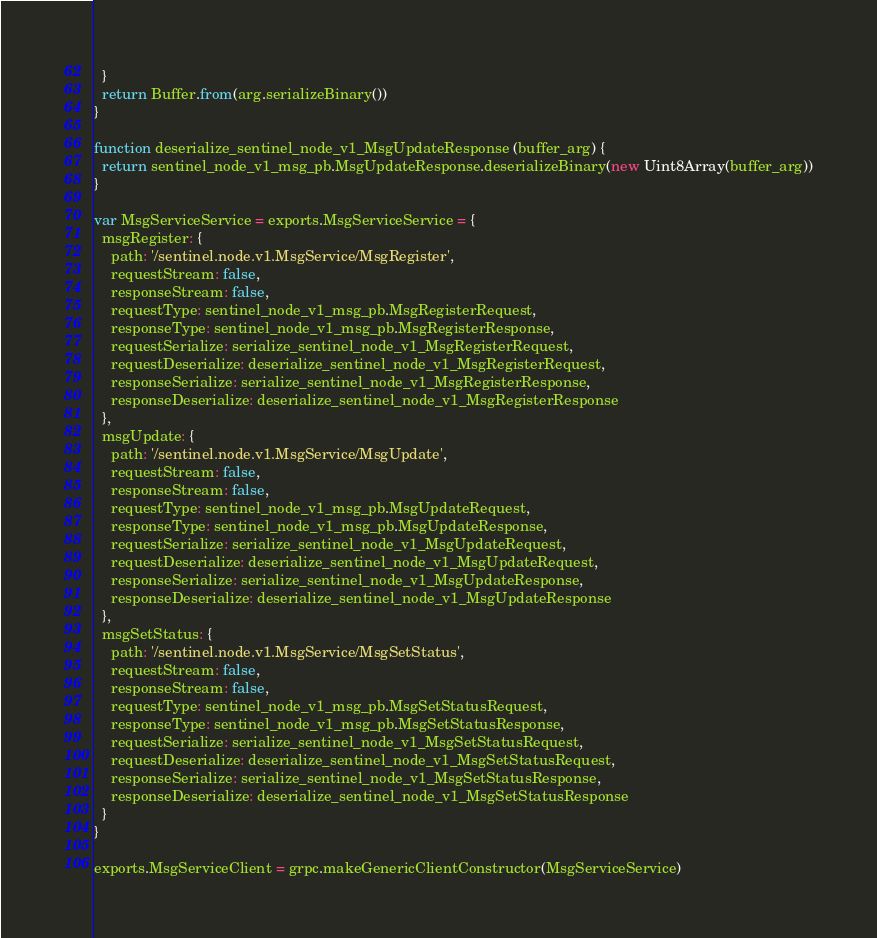<code> <loc_0><loc_0><loc_500><loc_500><_JavaScript_>  }
  return Buffer.from(arg.serializeBinary())
}

function deserialize_sentinel_node_v1_MsgUpdateResponse (buffer_arg) {
  return sentinel_node_v1_msg_pb.MsgUpdateResponse.deserializeBinary(new Uint8Array(buffer_arg))
}

var MsgServiceService = exports.MsgServiceService = {
  msgRegister: {
    path: '/sentinel.node.v1.MsgService/MsgRegister',
    requestStream: false,
    responseStream: false,
    requestType: sentinel_node_v1_msg_pb.MsgRegisterRequest,
    responseType: sentinel_node_v1_msg_pb.MsgRegisterResponse,
    requestSerialize: serialize_sentinel_node_v1_MsgRegisterRequest,
    requestDeserialize: deserialize_sentinel_node_v1_MsgRegisterRequest,
    responseSerialize: serialize_sentinel_node_v1_MsgRegisterResponse,
    responseDeserialize: deserialize_sentinel_node_v1_MsgRegisterResponse
  },
  msgUpdate: {
    path: '/sentinel.node.v1.MsgService/MsgUpdate',
    requestStream: false,
    responseStream: false,
    requestType: sentinel_node_v1_msg_pb.MsgUpdateRequest,
    responseType: sentinel_node_v1_msg_pb.MsgUpdateResponse,
    requestSerialize: serialize_sentinel_node_v1_MsgUpdateRequest,
    requestDeserialize: deserialize_sentinel_node_v1_MsgUpdateRequest,
    responseSerialize: serialize_sentinel_node_v1_MsgUpdateResponse,
    responseDeserialize: deserialize_sentinel_node_v1_MsgUpdateResponse
  },
  msgSetStatus: {
    path: '/sentinel.node.v1.MsgService/MsgSetStatus',
    requestStream: false,
    responseStream: false,
    requestType: sentinel_node_v1_msg_pb.MsgSetStatusRequest,
    responseType: sentinel_node_v1_msg_pb.MsgSetStatusResponse,
    requestSerialize: serialize_sentinel_node_v1_MsgSetStatusRequest,
    requestDeserialize: deserialize_sentinel_node_v1_MsgSetStatusRequest,
    responseSerialize: serialize_sentinel_node_v1_MsgSetStatusResponse,
    responseDeserialize: deserialize_sentinel_node_v1_MsgSetStatusResponse
  }
}

exports.MsgServiceClient = grpc.makeGenericClientConstructor(MsgServiceService)
</code> 